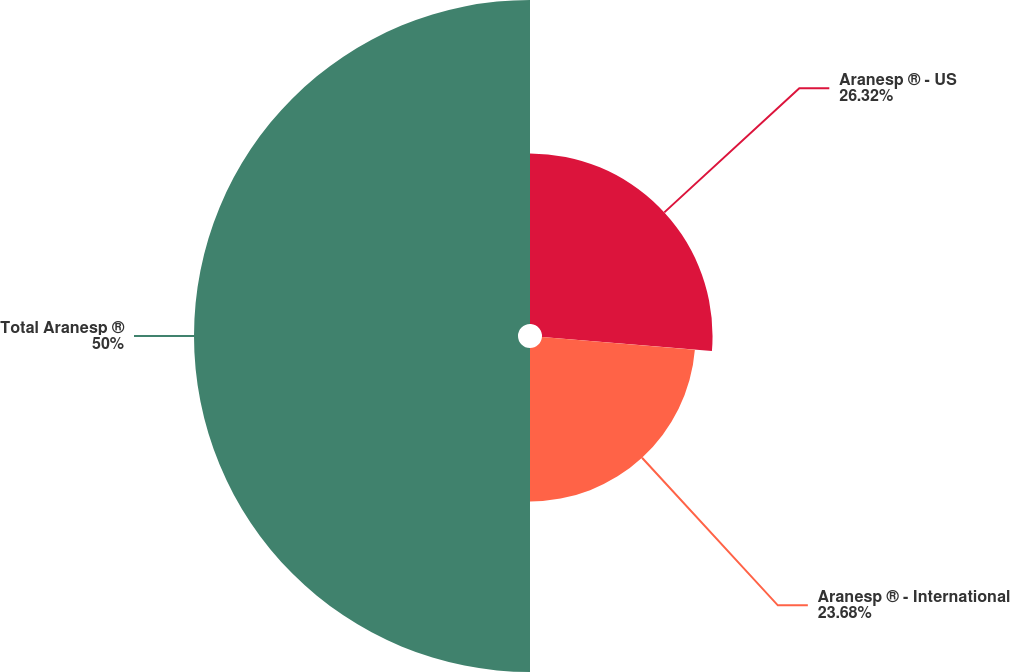Convert chart. <chart><loc_0><loc_0><loc_500><loc_500><pie_chart><fcel>Aranesp ® - US<fcel>Aranesp ® - International<fcel>Total Aranesp ®<nl><fcel>26.32%<fcel>23.68%<fcel>50.0%<nl></chart> 